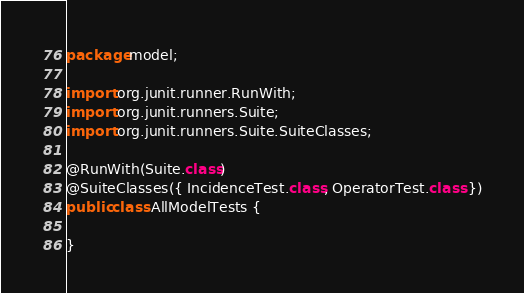Convert code to text. <code><loc_0><loc_0><loc_500><loc_500><_Java_>package model;

import org.junit.runner.RunWith;
import org.junit.runners.Suite;
import org.junit.runners.Suite.SuiteClasses;

@RunWith(Suite.class)
@SuiteClasses({ IncidenceTest.class, OperatorTest.class })
public class AllModelTests {

}
</code> 